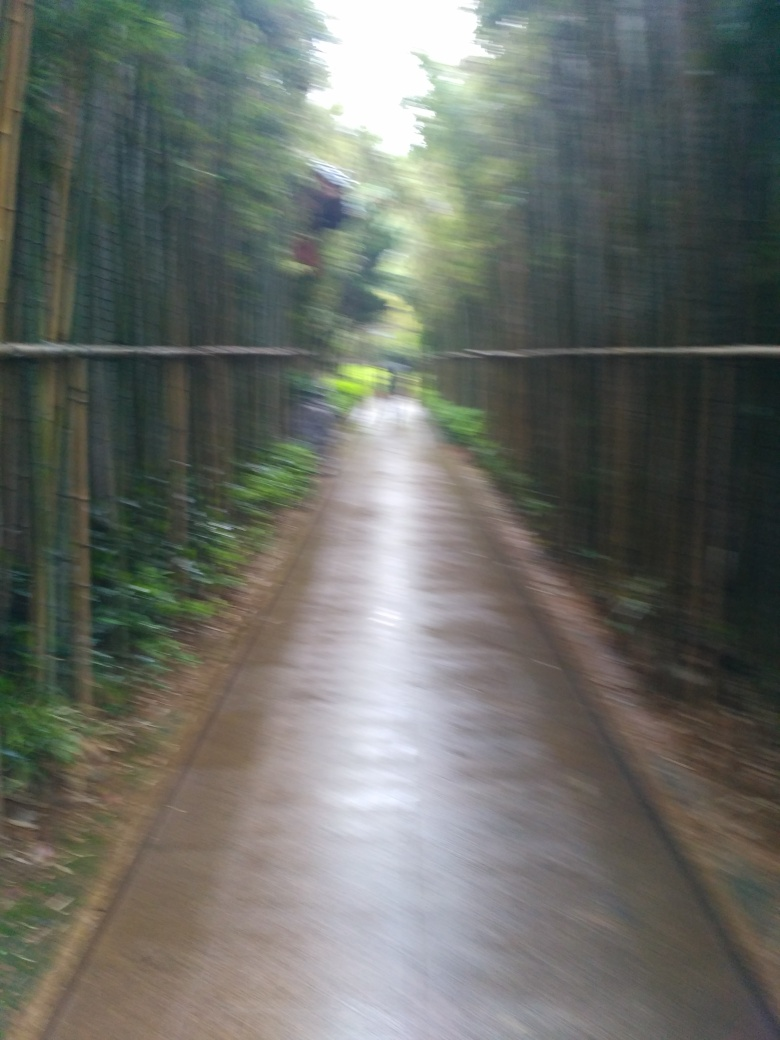Is this kind of setting usual for bamboo to grow, and how is bamboo cultivation beneficial to the environment? Yes, bamboo typically thrives in settings like the one depicted, where there is ample moisture and warm climate. Moreover, bamboo cultivation is beneficial to the environment as it requires no fertilizers or pesticides, grows quickly, and absorbs large quantities of CO2, making it a sustainable and eco-friendly choice. 